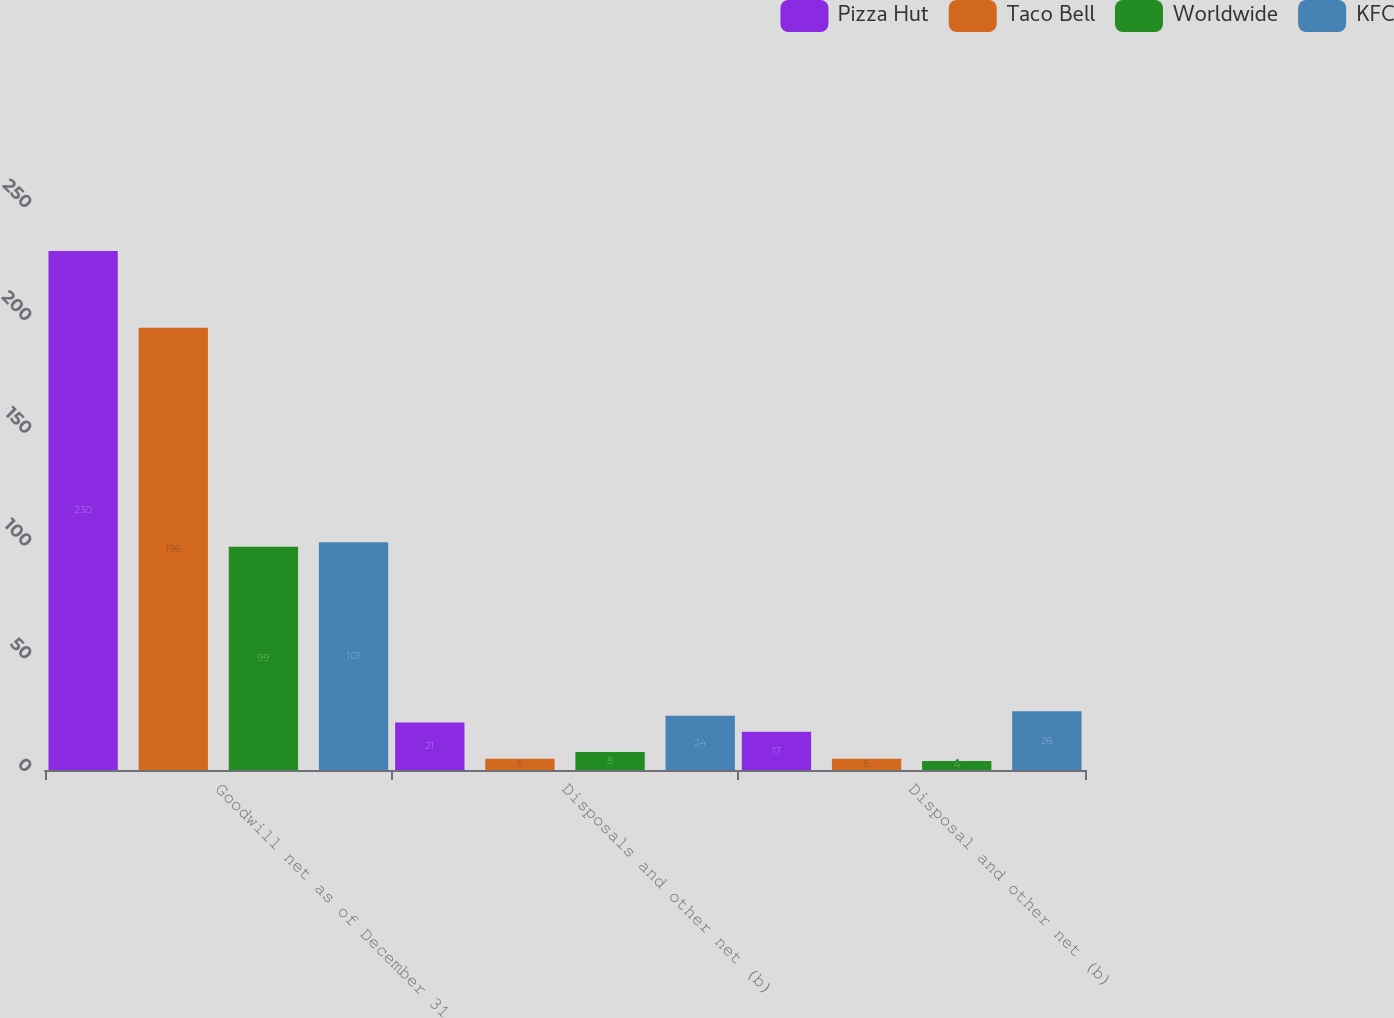<chart> <loc_0><loc_0><loc_500><loc_500><stacked_bar_chart><ecel><fcel>Goodwill net as of December 31<fcel>Disposals and other net (b)<fcel>Disposal and other net (b)<nl><fcel>Pizza Hut<fcel>230<fcel>21<fcel>17<nl><fcel>Taco Bell<fcel>196<fcel>5<fcel>5<nl><fcel>Worldwide<fcel>99<fcel>8<fcel>4<nl><fcel>KFC<fcel>101<fcel>24<fcel>26<nl></chart> 